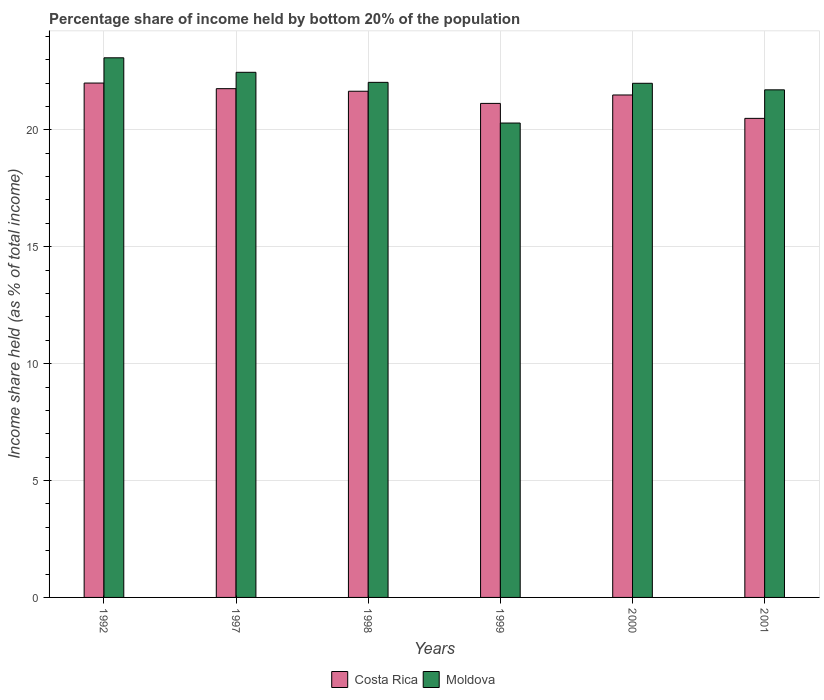How many different coloured bars are there?
Provide a short and direct response. 2. Are the number of bars per tick equal to the number of legend labels?
Make the answer very short. Yes. Are the number of bars on each tick of the X-axis equal?
Keep it short and to the point. Yes. What is the label of the 3rd group of bars from the left?
Ensure brevity in your answer.  1998. In how many cases, is the number of bars for a given year not equal to the number of legend labels?
Make the answer very short. 0. What is the share of income held by bottom 20% of the population in Moldova in 2000?
Offer a terse response. 21.99. Across all years, what is the maximum share of income held by bottom 20% of the population in Costa Rica?
Offer a very short reply. 22. Across all years, what is the minimum share of income held by bottom 20% of the population in Moldova?
Your answer should be compact. 20.29. In which year was the share of income held by bottom 20% of the population in Costa Rica maximum?
Ensure brevity in your answer.  1992. In which year was the share of income held by bottom 20% of the population in Costa Rica minimum?
Keep it short and to the point. 2001. What is the total share of income held by bottom 20% of the population in Moldova in the graph?
Give a very brief answer. 131.56. What is the difference between the share of income held by bottom 20% of the population in Moldova in 1999 and that in 2001?
Keep it short and to the point. -1.42. What is the difference between the share of income held by bottom 20% of the population in Moldova in 1997 and the share of income held by bottom 20% of the population in Costa Rica in 2001?
Give a very brief answer. 1.97. What is the average share of income held by bottom 20% of the population in Moldova per year?
Offer a very short reply. 21.93. In the year 2001, what is the difference between the share of income held by bottom 20% of the population in Moldova and share of income held by bottom 20% of the population in Costa Rica?
Your answer should be compact. 1.22. In how many years, is the share of income held by bottom 20% of the population in Moldova greater than 23 %?
Provide a short and direct response. 1. What is the ratio of the share of income held by bottom 20% of the population in Costa Rica in 1992 to that in 1998?
Your answer should be compact. 1.02. Is the share of income held by bottom 20% of the population in Costa Rica in 1998 less than that in 1999?
Provide a short and direct response. No. What is the difference between the highest and the second highest share of income held by bottom 20% of the population in Moldova?
Provide a short and direct response. 0.62. What is the difference between the highest and the lowest share of income held by bottom 20% of the population in Costa Rica?
Give a very brief answer. 1.51. In how many years, is the share of income held by bottom 20% of the population in Costa Rica greater than the average share of income held by bottom 20% of the population in Costa Rica taken over all years?
Provide a succinct answer. 4. What does the 2nd bar from the right in 1999 represents?
Ensure brevity in your answer.  Costa Rica. How many years are there in the graph?
Your answer should be very brief. 6. What is the difference between two consecutive major ticks on the Y-axis?
Your response must be concise. 5. Are the values on the major ticks of Y-axis written in scientific E-notation?
Your response must be concise. No. How many legend labels are there?
Offer a terse response. 2. How are the legend labels stacked?
Keep it short and to the point. Horizontal. What is the title of the graph?
Ensure brevity in your answer.  Percentage share of income held by bottom 20% of the population. Does "Serbia" appear as one of the legend labels in the graph?
Make the answer very short. No. What is the label or title of the X-axis?
Your response must be concise. Years. What is the label or title of the Y-axis?
Your answer should be very brief. Income share held (as % of total income). What is the Income share held (as % of total income) in Costa Rica in 1992?
Offer a very short reply. 22. What is the Income share held (as % of total income) in Moldova in 1992?
Provide a succinct answer. 23.08. What is the Income share held (as % of total income) in Costa Rica in 1997?
Provide a succinct answer. 21.76. What is the Income share held (as % of total income) in Moldova in 1997?
Provide a short and direct response. 22.46. What is the Income share held (as % of total income) of Costa Rica in 1998?
Your answer should be compact. 21.65. What is the Income share held (as % of total income) of Moldova in 1998?
Provide a succinct answer. 22.03. What is the Income share held (as % of total income) of Costa Rica in 1999?
Offer a terse response. 21.13. What is the Income share held (as % of total income) in Moldova in 1999?
Your answer should be compact. 20.29. What is the Income share held (as % of total income) of Costa Rica in 2000?
Make the answer very short. 21.49. What is the Income share held (as % of total income) in Moldova in 2000?
Your response must be concise. 21.99. What is the Income share held (as % of total income) of Costa Rica in 2001?
Offer a very short reply. 20.49. What is the Income share held (as % of total income) in Moldova in 2001?
Ensure brevity in your answer.  21.71. Across all years, what is the maximum Income share held (as % of total income) of Moldova?
Your answer should be very brief. 23.08. Across all years, what is the minimum Income share held (as % of total income) in Costa Rica?
Your answer should be compact. 20.49. Across all years, what is the minimum Income share held (as % of total income) in Moldova?
Your answer should be very brief. 20.29. What is the total Income share held (as % of total income) of Costa Rica in the graph?
Your answer should be compact. 128.52. What is the total Income share held (as % of total income) in Moldova in the graph?
Ensure brevity in your answer.  131.56. What is the difference between the Income share held (as % of total income) in Costa Rica in 1992 and that in 1997?
Your answer should be very brief. 0.24. What is the difference between the Income share held (as % of total income) of Moldova in 1992 and that in 1997?
Offer a terse response. 0.62. What is the difference between the Income share held (as % of total income) of Moldova in 1992 and that in 1998?
Give a very brief answer. 1.05. What is the difference between the Income share held (as % of total income) in Costa Rica in 1992 and that in 1999?
Give a very brief answer. 0.87. What is the difference between the Income share held (as % of total income) of Moldova in 1992 and that in 1999?
Offer a terse response. 2.79. What is the difference between the Income share held (as % of total income) of Costa Rica in 1992 and that in 2000?
Provide a short and direct response. 0.51. What is the difference between the Income share held (as % of total income) in Moldova in 1992 and that in 2000?
Give a very brief answer. 1.09. What is the difference between the Income share held (as % of total income) of Costa Rica in 1992 and that in 2001?
Provide a succinct answer. 1.51. What is the difference between the Income share held (as % of total income) of Moldova in 1992 and that in 2001?
Your answer should be very brief. 1.37. What is the difference between the Income share held (as % of total income) in Costa Rica in 1997 and that in 1998?
Make the answer very short. 0.11. What is the difference between the Income share held (as % of total income) of Moldova in 1997 and that in 1998?
Your answer should be compact. 0.43. What is the difference between the Income share held (as % of total income) of Costa Rica in 1997 and that in 1999?
Ensure brevity in your answer.  0.63. What is the difference between the Income share held (as % of total income) of Moldova in 1997 and that in 1999?
Your answer should be compact. 2.17. What is the difference between the Income share held (as % of total income) in Costa Rica in 1997 and that in 2000?
Make the answer very short. 0.27. What is the difference between the Income share held (as % of total income) in Moldova in 1997 and that in 2000?
Your response must be concise. 0.47. What is the difference between the Income share held (as % of total income) of Costa Rica in 1997 and that in 2001?
Make the answer very short. 1.27. What is the difference between the Income share held (as % of total income) of Moldova in 1997 and that in 2001?
Keep it short and to the point. 0.75. What is the difference between the Income share held (as % of total income) in Costa Rica in 1998 and that in 1999?
Keep it short and to the point. 0.52. What is the difference between the Income share held (as % of total income) in Moldova in 1998 and that in 1999?
Provide a succinct answer. 1.74. What is the difference between the Income share held (as % of total income) of Costa Rica in 1998 and that in 2000?
Offer a very short reply. 0.16. What is the difference between the Income share held (as % of total income) in Costa Rica in 1998 and that in 2001?
Ensure brevity in your answer.  1.16. What is the difference between the Income share held (as % of total income) of Moldova in 1998 and that in 2001?
Give a very brief answer. 0.32. What is the difference between the Income share held (as % of total income) of Costa Rica in 1999 and that in 2000?
Your answer should be very brief. -0.36. What is the difference between the Income share held (as % of total income) in Moldova in 1999 and that in 2000?
Offer a very short reply. -1.7. What is the difference between the Income share held (as % of total income) in Costa Rica in 1999 and that in 2001?
Provide a succinct answer. 0.64. What is the difference between the Income share held (as % of total income) in Moldova in 1999 and that in 2001?
Offer a very short reply. -1.42. What is the difference between the Income share held (as % of total income) in Costa Rica in 2000 and that in 2001?
Offer a very short reply. 1. What is the difference between the Income share held (as % of total income) of Moldova in 2000 and that in 2001?
Give a very brief answer. 0.28. What is the difference between the Income share held (as % of total income) in Costa Rica in 1992 and the Income share held (as % of total income) in Moldova in 1997?
Provide a succinct answer. -0.46. What is the difference between the Income share held (as % of total income) in Costa Rica in 1992 and the Income share held (as % of total income) in Moldova in 1998?
Your answer should be very brief. -0.03. What is the difference between the Income share held (as % of total income) of Costa Rica in 1992 and the Income share held (as % of total income) of Moldova in 1999?
Keep it short and to the point. 1.71. What is the difference between the Income share held (as % of total income) in Costa Rica in 1992 and the Income share held (as % of total income) in Moldova in 2001?
Ensure brevity in your answer.  0.29. What is the difference between the Income share held (as % of total income) in Costa Rica in 1997 and the Income share held (as % of total income) in Moldova in 1998?
Your response must be concise. -0.27. What is the difference between the Income share held (as % of total income) in Costa Rica in 1997 and the Income share held (as % of total income) in Moldova in 1999?
Your answer should be compact. 1.47. What is the difference between the Income share held (as % of total income) of Costa Rica in 1997 and the Income share held (as % of total income) of Moldova in 2000?
Offer a very short reply. -0.23. What is the difference between the Income share held (as % of total income) in Costa Rica in 1998 and the Income share held (as % of total income) in Moldova in 1999?
Offer a terse response. 1.36. What is the difference between the Income share held (as % of total income) of Costa Rica in 1998 and the Income share held (as % of total income) of Moldova in 2000?
Provide a succinct answer. -0.34. What is the difference between the Income share held (as % of total income) in Costa Rica in 1998 and the Income share held (as % of total income) in Moldova in 2001?
Provide a succinct answer. -0.06. What is the difference between the Income share held (as % of total income) of Costa Rica in 1999 and the Income share held (as % of total income) of Moldova in 2000?
Your response must be concise. -0.86. What is the difference between the Income share held (as % of total income) in Costa Rica in 1999 and the Income share held (as % of total income) in Moldova in 2001?
Provide a succinct answer. -0.58. What is the difference between the Income share held (as % of total income) of Costa Rica in 2000 and the Income share held (as % of total income) of Moldova in 2001?
Your answer should be compact. -0.22. What is the average Income share held (as % of total income) of Costa Rica per year?
Provide a succinct answer. 21.42. What is the average Income share held (as % of total income) of Moldova per year?
Provide a succinct answer. 21.93. In the year 1992, what is the difference between the Income share held (as % of total income) in Costa Rica and Income share held (as % of total income) in Moldova?
Make the answer very short. -1.08. In the year 1997, what is the difference between the Income share held (as % of total income) of Costa Rica and Income share held (as % of total income) of Moldova?
Offer a terse response. -0.7. In the year 1998, what is the difference between the Income share held (as % of total income) of Costa Rica and Income share held (as % of total income) of Moldova?
Your response must be concise. -0.38. In the year 1999, what is the difference between the Income share held (as % of total income) in Costa Rica and Income share held (as % of total income) in Moldova?
Provide a short and direct response. 0.84. In the year 2001, what is the difference between the Income share held (as % of total income) of Costa Rica and Income share held (as % of total income) of Moldova?
Provide a short and direct response. -1.22. What is the ratio of the Income share held (as % of total income) in Costa Rica in 1992 to that in 1997?
Ensure brevity in your answer.  1.01. What is the ratio of the Income share held (as % of total income) of Moldova in 1992 to that in 1997?
Your response must be concise. 1.03. What is the ratio of the Income share held (as % of total income) of Costa Rica in 1992 to that in 1998?
Keep it short and to the point. 1.02. What is the ratio of the Income share held (as % of total income) in Moldova in 1992 to that in 1998?
Your answer should be very brief. 1.05. What is the ratio of the Income share held (as % of total income) of Costa Rica in 1992 to that in 1999?
Ensure brevity in your answer.  1.04. What is the ratio of the Income share held (as % of total income) of Moldova in 1992 to that in 1999?
Offer a very short reply. 1.14. What is the ratio of the Income share held (as % of total income) of Costa Rica in 1992 to that in 2000?
Ensure brevity in your answer.  1.02. What is the ratio of the Income share held (as % of total income) of Moldova in 1992 to that in 2000?
Offer a very short reply. 1.05. What is the ratio of the Income share held (as % of total income) of Costa Rica in 1992 to that in 2001?
Make the answer very short. 1.07. What is the ratio of the Income share held (as % of total income) in Moldova in 1992 to that in 2001?
Your response must be concise. 1.06. What is the ratio of the Income share held (as % of total income) of Moldova in 1997 to that in 1998?
Keep it short and to the point. 1.02. What is the ratio of the Income share held (as % of total income) in Costa Rica in 1997 to that in 1999?
Your response must be concise. 1.03. What is the ratio of the Income share held (as % of total income) of Moldova in 1997 to that in 1999?
Your answer should be very brief. 1.11. What is the ratio of the Income share held (as % of total income) in Costa Rica in 1997 to that in 2000?
Your response must be concise. 1.01. What is the ratio of the Income share held (as % of total income) of Moldova in 1997 to that in 2000?
Give a very brief answer. 1.02. What is the ratio of the Income share held (as % of total income) in Costa Rica in 1997 to that in 2001?
Offer a terse response. 1.06. What is the ratio of the Income share held (as % of total income) of Moldova in 1997 to that in 2001?
Offer a terse response. 1.03. What is the ratio of the Income share held (as % of total income) of Costa Rica in 1998 to that in 1999?
Give a very brief answer. 1.02. What is the ratio of the Income share held (as % of total income) of Moldova in 1998 to that in 1999?
Ensure brevity in your answer.  1.09. What is the ratio of the Income share held (as % of total income) in Costa Rica in 1998 to that in 2000?
Offer a terse response. 1.01. What is the ratio of the Income share held (as % of total income) of Costa Rica in 1998 to that in 2001?
Your answer should be very brief. 1.06. What is the ratio of the Income share held (as % of total income) in Moldova in 1998 to that in 2001?
Keep it short and to the point. 1.01. What is the ratio of the Income share held (as % of total income) in Costa Rica in 1999 to that in 2000?
Offer a terse response. 0.98. What is the ratio of the Income share held (as % of total income) in Moldova in 1999 to that in 2000?
Offer a terse response. 0.92. What is the ratio of the Income share held (as % of total income) of Costa Rica in 1999 to that in 2001?
Offer a very short reply. 1.03. What is the ratio of the Income share held (as % of total income) in Moldova in 1999 to that in 2001?
Provide a succinct answer. 0.93. What is the ratio of the Income share held (as % of total income) in Costa Rica in 2000 to that in 2001?
Your answer should be compact. 1.05. What is the ratio of the Income share held (as % of total income) in Moldova in 2000 to that in 2001?
Keep it short and to the point. 1.01. What is the difference between the highest and the second highest Income share held (as % of total income) of Costa Rica?
Provide a succinct answer. 0.24. What is the difference between the highest and the second highest Income share held (as % of total income) in Moldova?
Keep it short and to the point. 0.62. What is the difference between the highest and the lowest Income share held (as % of total income) of Costa Rica?
Your answer should be very brief. 1.51. What is the difference between the highest and the lowest Income share held (as % of total income) in Moldova?
Your answer should be compact. 2.79. 